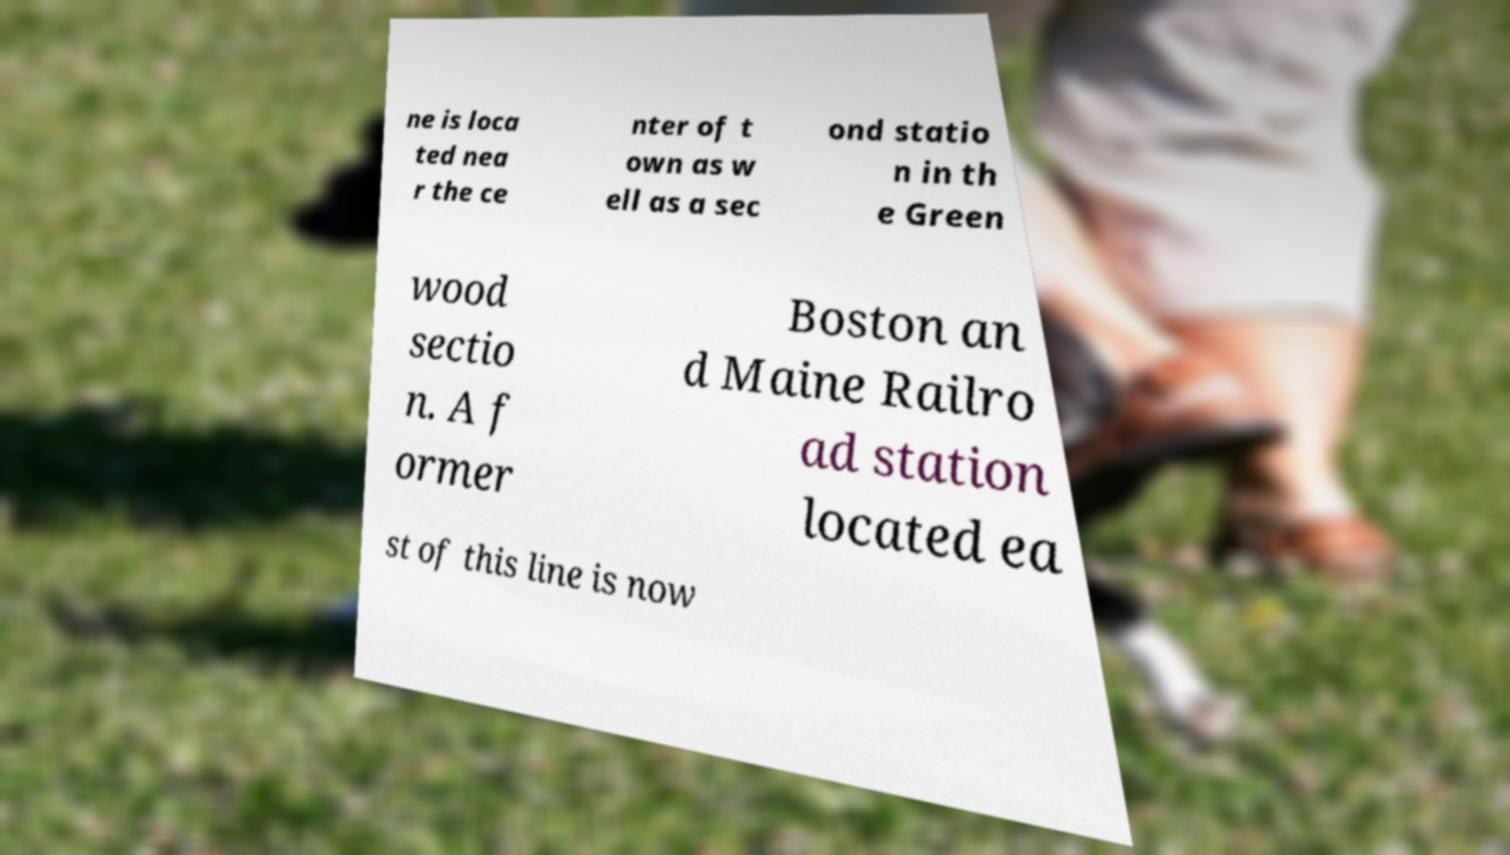Could you assist in decoding the text presented in this image and type it out clearly? ne is loca ted nea r the ce nter of t own as w ell as a sec ond statio n in th e Green wood sectio n. A f ormer Boston an d Maine Railro ad station located ea st of this line is now 